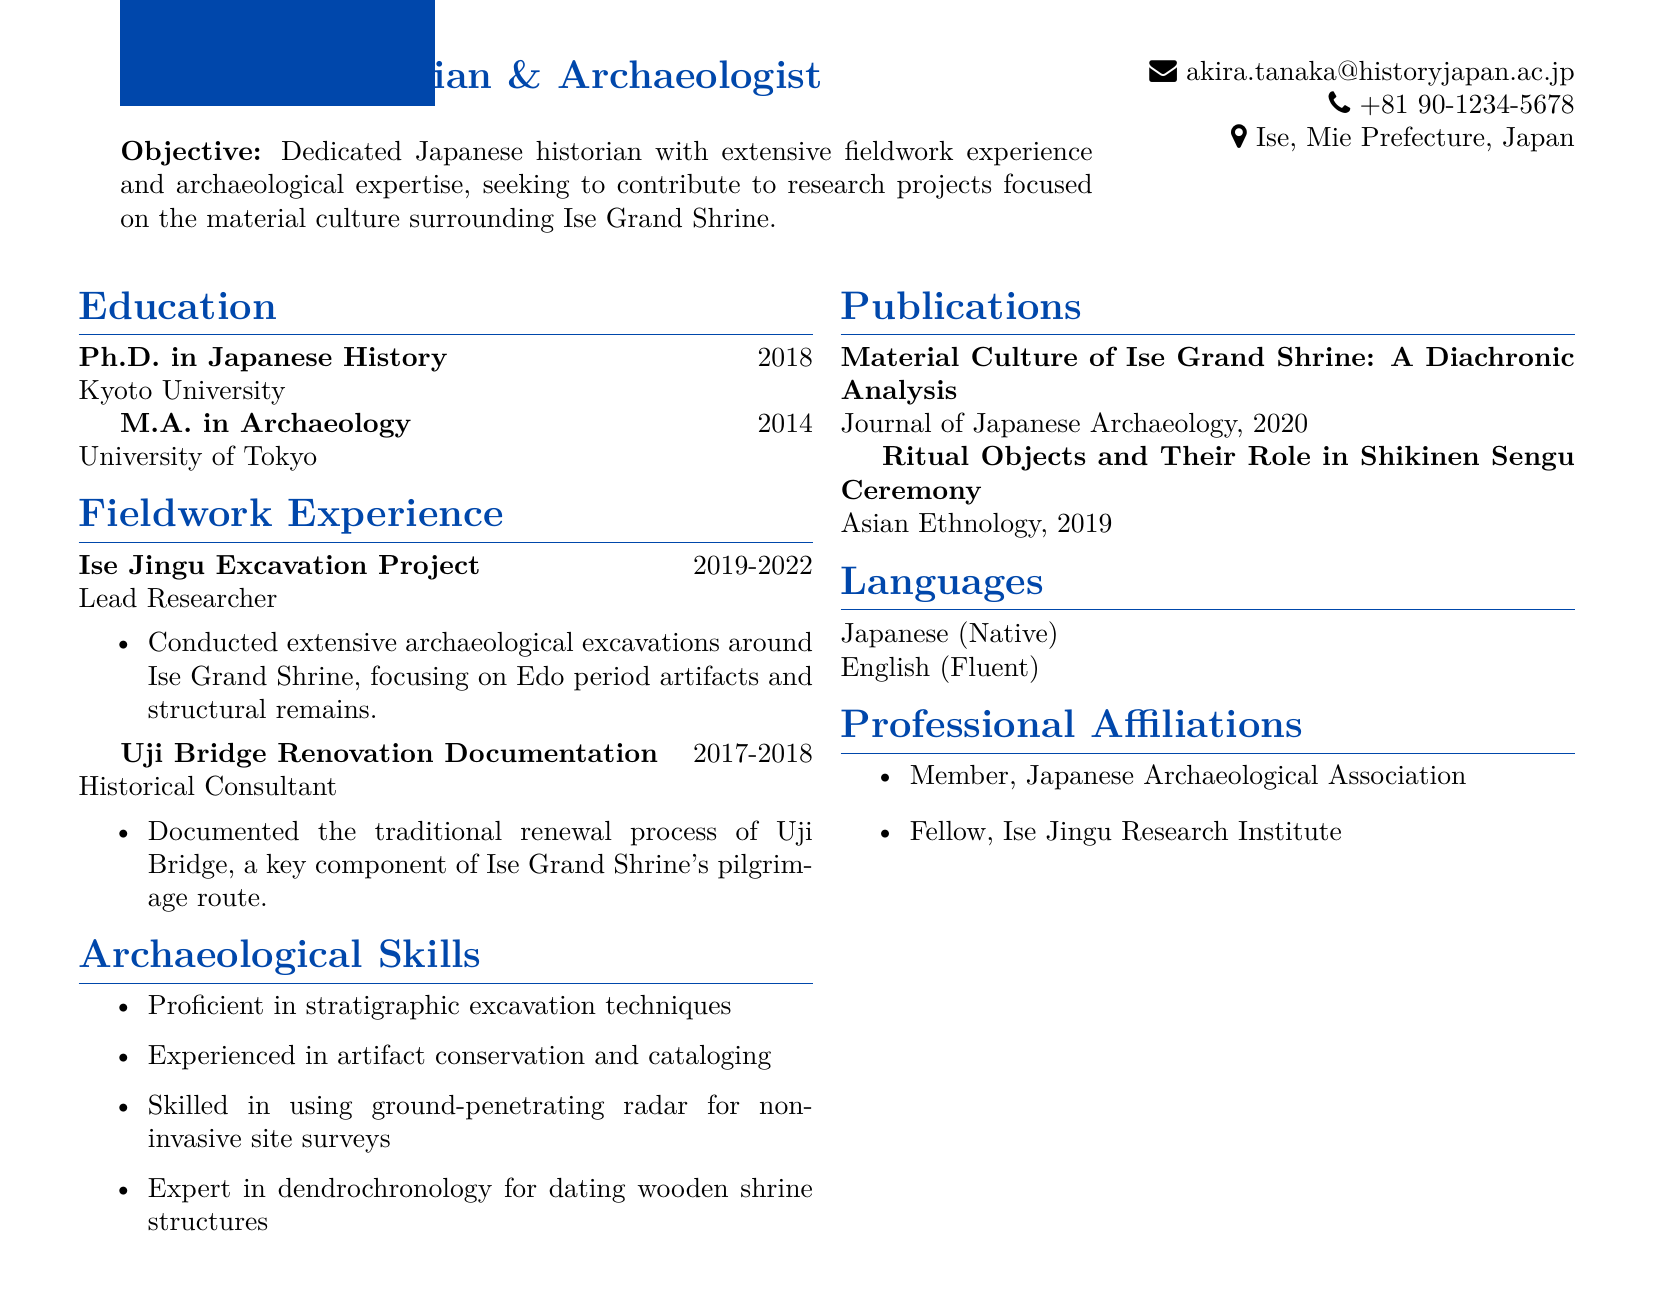what is the name of the applicant? The name of the applicant is explicitly stated in the personal information section of the resume.
Answer: Akira Tanaka what is the objective of the applicant? The objective is a summary statement that describes the applicant's professional goals.
Answer: Dedicated Japanese historian with extensive fieldwork experience and archaeological expertise, seeking to contribute to research projects focused on the material culture surrounding Ise Grand Shrine which university did the applicant receive their Ph.D. from? The educational qualifications list the institutions where the degrees were obtained.
Answer: Kyoto University how many years did the Ise Jingu Excavation Project last? The duration of the project is mentioned in the fieldwork experience section of the resume.
Answer: 3 years what skill involves using ground-penetrating radar? The skills listed provide insights into the applicant's expertise in specific archaeological techniques.
Answer: Skilled in using ground-penetrating radar for non-invasive site surveys in which year was the publication "Ritual Objects and Their Role in Shikinen Sengu Ceremony" released? The publication information includes the years associated with each listed work.
Answer: 2019 what professional affiliation does the applicant have that relates to the Ise Grand Shrine? The professional affiliations section includes organizational memberships connected to the applicant's field.
Answer: Fellow, Ise Jingu Research Institute what role did the applicant serve in the Uji Bridge Renovation Documentation? The fieldwork experience outlines the applicant's roles in different projects.
Answer: Historical Consultant 